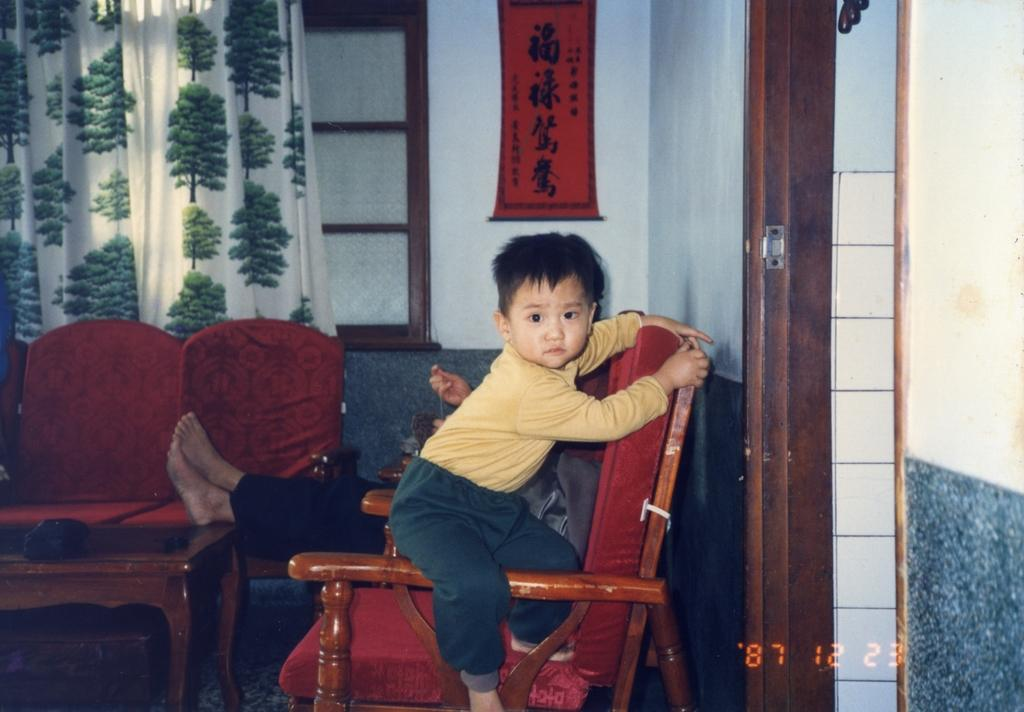What is the boy doing in the image? The boy is sitting on the sofa in the image. Who is sitting behind the boy in the image? There is a person sitting behind the boy in the image. What can be seen in the background of the image? There is a window in the background of the image. What is associated with the window in the image? There is a curtain associated with the window in the image. What is on the wall in the image? There is a calendar on the wall in the image. What type of pet is sitting next to the boy in the image? There is no pet present in the image. 